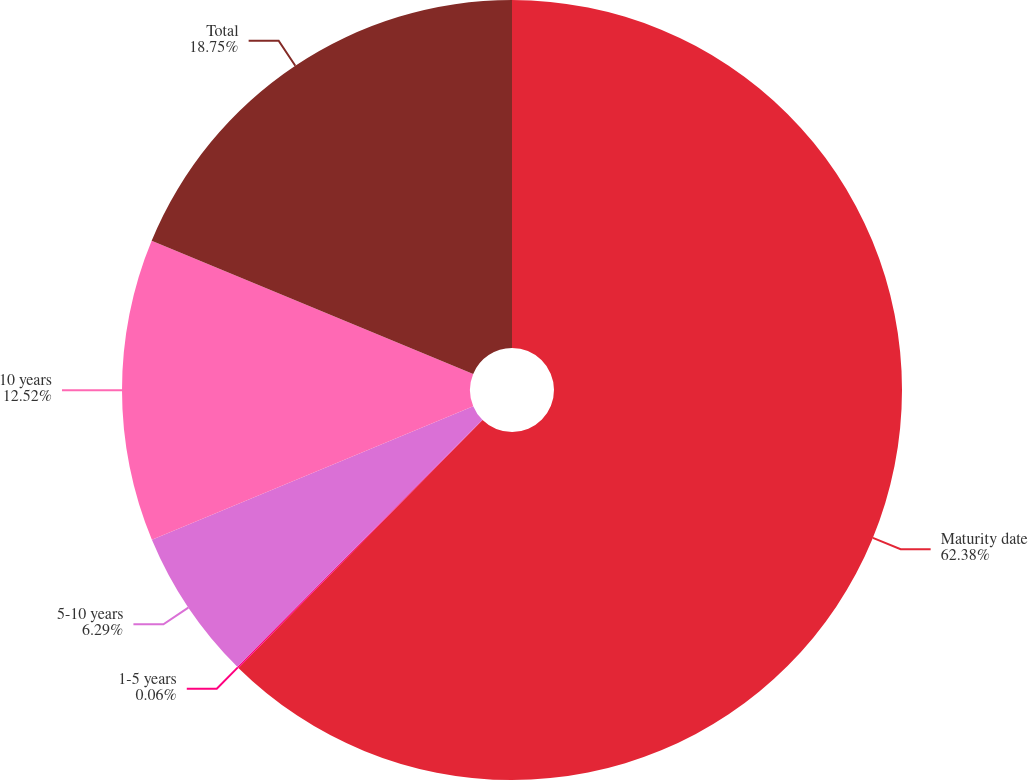Convert chart. <chart><loc_0><loc_0><loc_500><loc_500><pie_chart><fcel>Maturity date<fcel>1-5 years<fcel>5-10 years<fcel>10 years<fcel>Total<nl><fcel>62.37%<fcel>0.06%<fcel>6.29%<fcel>12.52%<fcel>18.75%<nl></chart> 